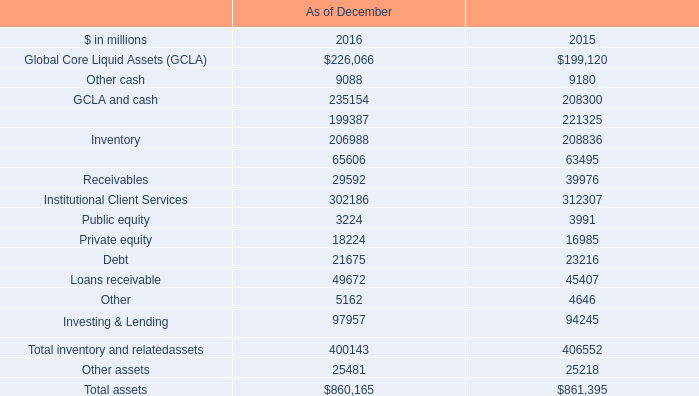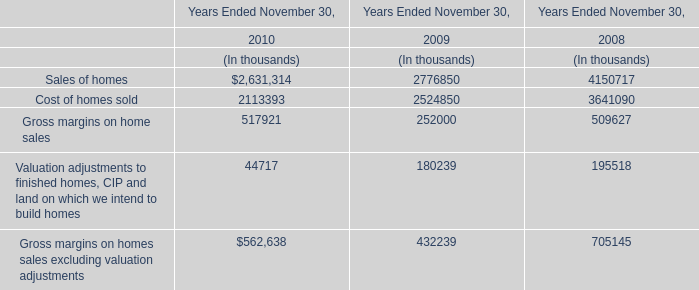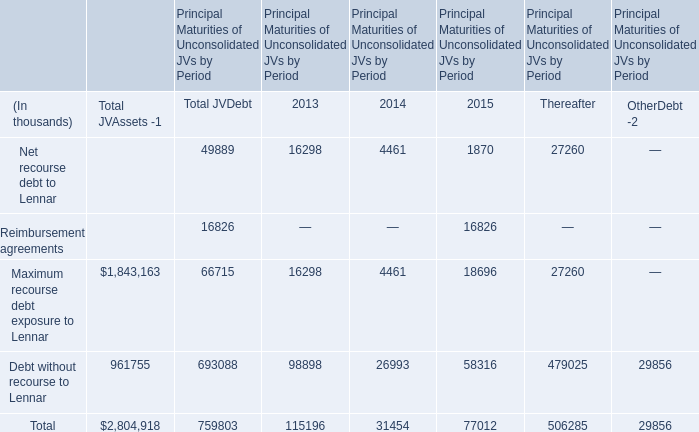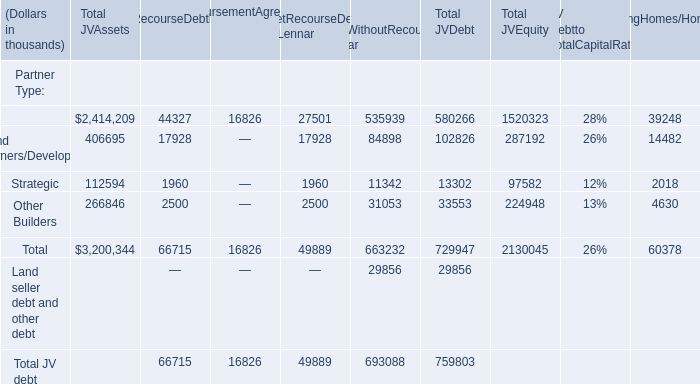what's the total amount of Other Builders of NetRecourseDebt toLennar, Secured client financing of As of December 2016, and Total of Principal Maturities of Unconsolidated JVs by Period 2015 ? 
Computations: ((2500.0 + 199387.0) + 77012.0)
Answer: 278899.0. 